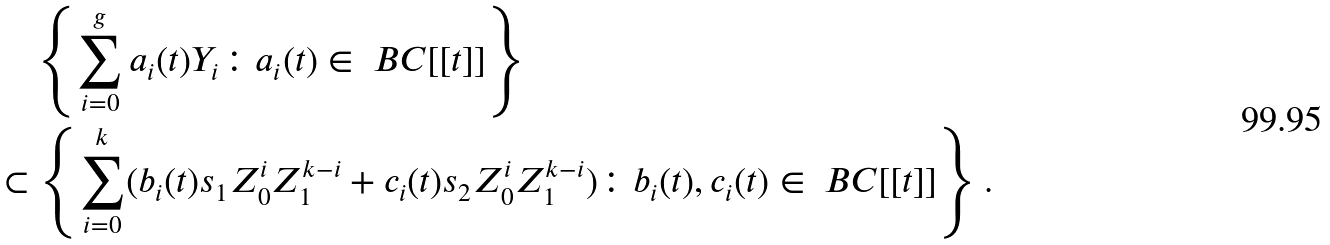Convert formula to latex. <formula><loc_0><loc_0><loc_500><loc_500>& \quad \left \{ \sum _ { i = 0 } ^ { g } a _ { i } ( t ) Y _ { i } \colon a _ { i } ( t ) \in \ B C [ [ t ] ] \right \} \\ & \subset \left \{ \sum _ { i = 0 } ^ { k } ( b _ { i } ( t ) s _ { 1 } Z _ { 0 } ^ { i } Z _ { 1 } ^ { k - i } + c _ { i } ( t ) s _ { 2 } Z _ { 0 } ^ { i } Z _ { 1 } ^ { k - i } ) \colon b _ { i } ( t ) , c _ { i } ( t ) \in \ B C [ [ t ] ] \right \} .</formula> 